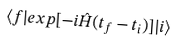<formula> <loc_0><loc_0><loc_500><loc_500>\langle f | e x p [ - i \hat { H } ( t _ { f } - t _ { i } ) ] | i \rangle</formula> 